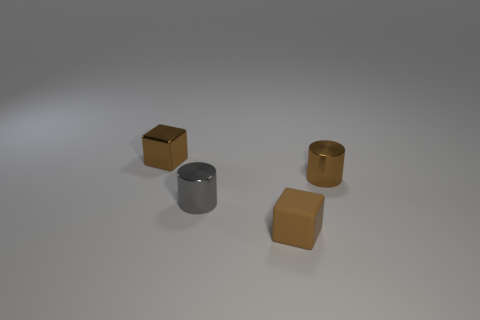Is the tiny shiny block the same color as the rubber block? While both the tiny shiny block and the rubber block share a similar brown hue, their materials affect the perception of color. The shiny block reflects light differently due to its metallic surface, making it appear to have various shades under different lighting conditions. The rubber block, with its matte finish, absorbs more light leading to a more consistent appearance of color. 